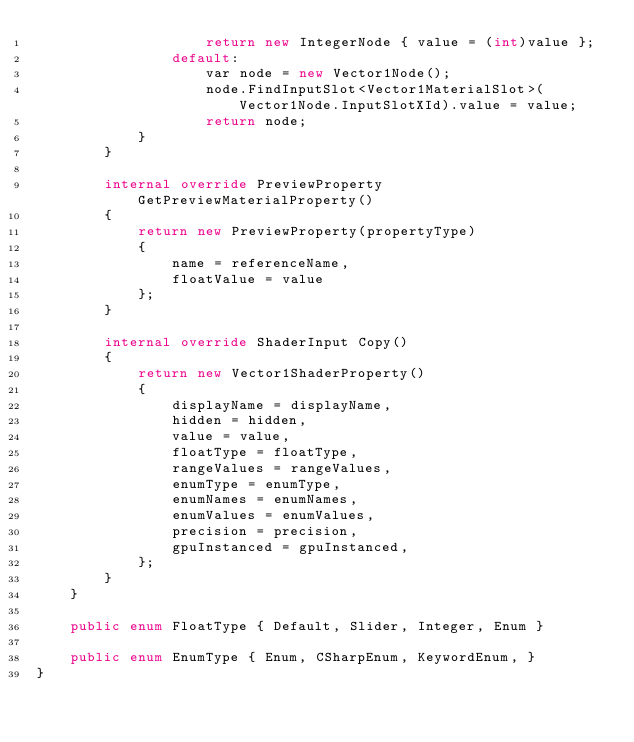Convert code to text. <code><loc_0><loc_0><loc_500><loc_500><_C#_>                    return new IntegerNode { value = (int)value };
                default:
                    var node = new Vector1Node();
                    node.FindInputSlot<Vector1MaterialSlot>(Vector1Node.InputSlotXId).value = value;
                    return node;
            }
        }

        internal override PreviewProperty GetPreviewMaterialProperty()
        {
            return new PreviewProperty(propertyType)
            {
                name = referenceName,
                floatValue = value
            };
        }

        internal override ShaderInput Copy()
        {
            return new Vector1ShaderProperty()
            {
                displayName = displayName,
                hidden = hidden,
                value = value,
                floatType = floatType,
                rangeValues = rangeValues,
                enumType = enumType,
                enumNames = enumNames,
                enumValues = enumValues,
                precision = precision,
                gpuInstanced = gpuInstanced,
            };
        }
    }

    public enum FloatType { Default, Slider, Integer, Enum }

    public enum EnumType { Enum, CSharpEnum, KeywordEnum, }
}
</code> 